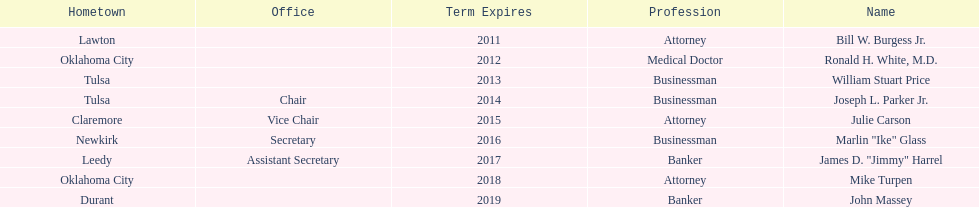In which state is the regent who shares a hometown with dr. ronald h. white, m.d.? Mike Turpen. 